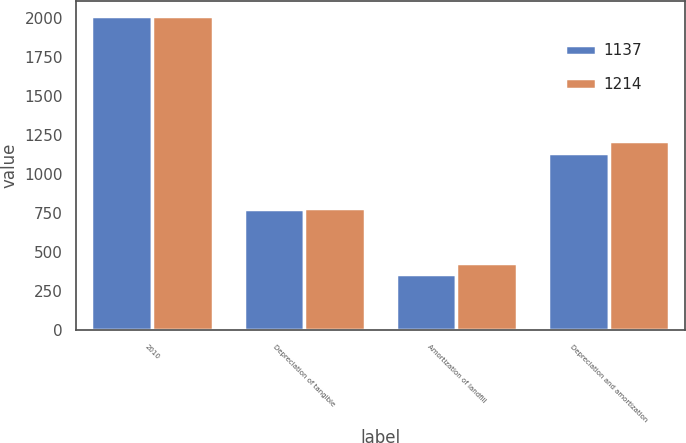<chart> <loc_0><loc_0><loc_500><loc_500><stacked_bar_chart><ecel><fcel>2010<fcel>Depreciation of tangible<fcel>Amortization of landfill<fcel>Depreciation and amortization<nl><fcel>1137<fcel>2009<fcel>779<fcel>358<fcel>1137<nl><fcel>1214<fcel>2008<fcel>785<fcel>429<fcel>1214<nl></chart> 